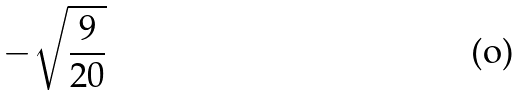<formula> <loc_0><loc_0><loc_500><loc_500>- \sqrt { \frac { 9 } { 2 0 } }</formula> 